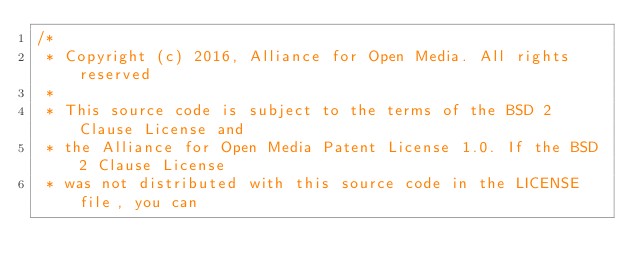<code> <loc_0><loc_0><loc_500><loc_500><_C_>/*
 * Copyright (c) 2016, Alliance for Open Media. All rights reserved
 *
 * This source code is subject to the terms of the BSD 2 Clause License and
 * the Alliance for Open Media Patent License 1.0. If the BSD 2 Clause License
 * was not distributed with this source code in the LICENSE file, you can</code> 